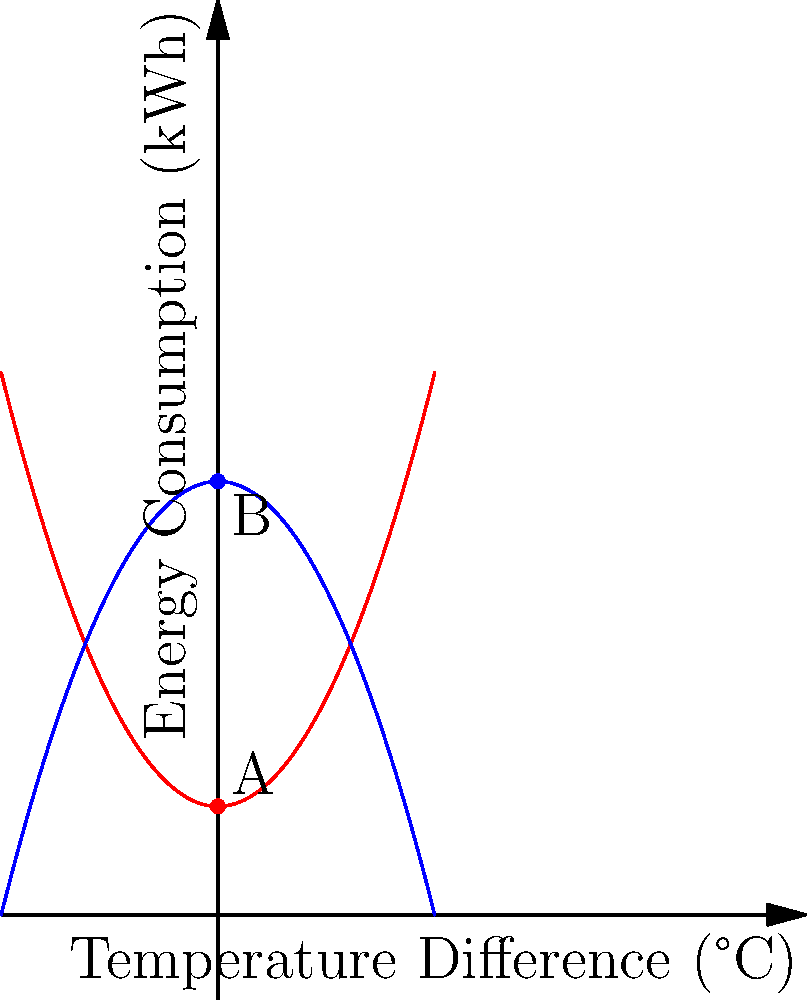Based on the temperature distribution heat map shown in the graph, which HVAC system configuration (A or B) is more energy-efficient, and by approximately what percentage does it reduce energy consumption when the temperature difference between indoor and outdoor is 0°C? To determine which HVAC system configuration is more energy-efficient and calculate the percentage of energy reduction, we'll follow these steps:

1. Identify the energy consumption for each system at 0°C temperature difference:
   - System A (red curve): $f(0) = 2$ kWh
   - System B (blue curve): $g(0) = 8$ kWh

2. Compare the energy consumption:
   System B consumes less energy at 0°C temperature difference, so it's more efficient.

3. Calculate the percentage of energy reduction:
   Percentage reduction = $\frac{\text{Difference in energy consumption}}{\text{Original energy consumption}} \times 100\%$
   
   $= \frac{8 - 2}{8} \times 100\%$
   $= \frac{6}{8} \times 100\%$
   $= 0.75 \times 100\%$
   $= 75\%$

Therefore, System B is more energy-efficient and reduces energy consumption by approximately 75% when the temperature difference is 0°C.
Answer: System B; 75% reduction 